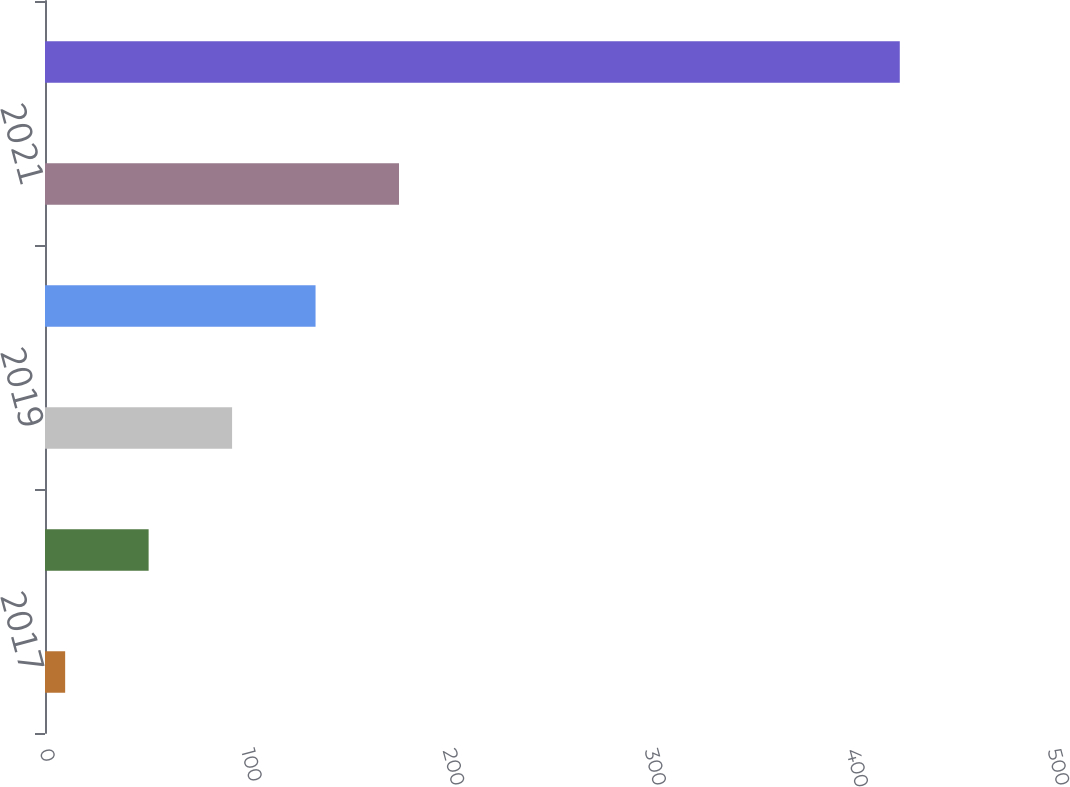Convert chart to OTSL. <chart><loc_0><loc_0><loc_500><loc_500><bar_chart><fcel>2017<fcel>2018<fcel>2019<fcel>2020<fcel>2021<fcel>2022 - 2026<nl><fcel>10<fcel>51.4<fcel>92.8<fcel>134.2<fcel>175.6<fcel>424<nl></chart> 